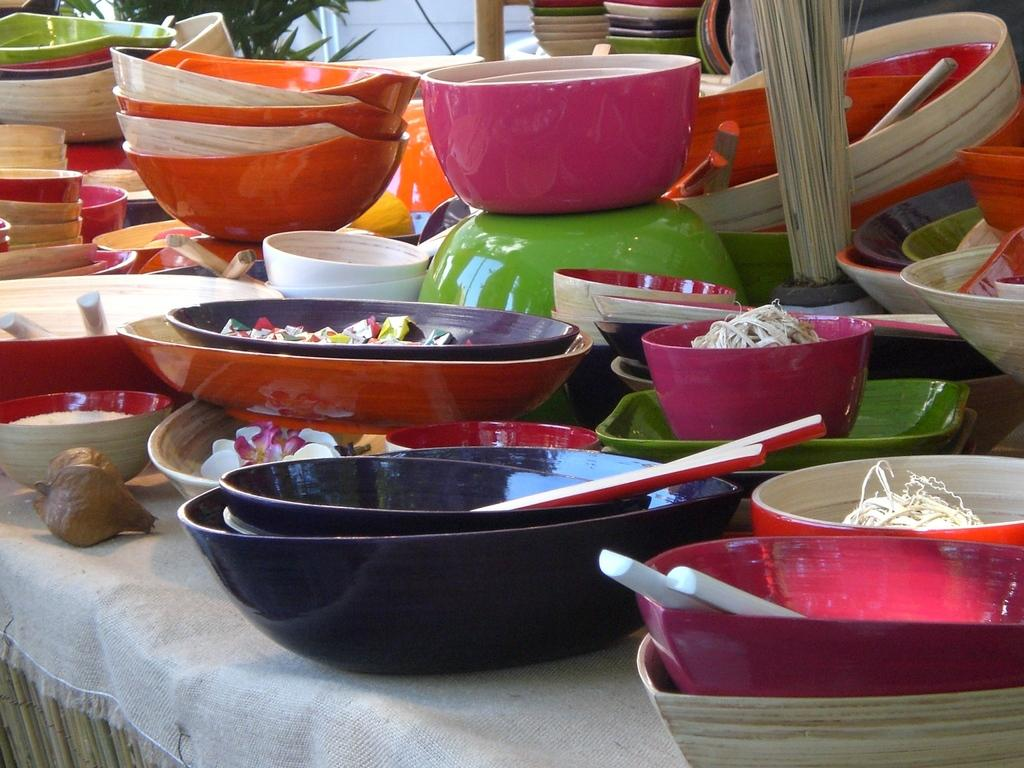What type of dishware is on the table in the image? There are multi-color bowls on the table. What is covering the table in the image? There is a white cloth in the image. What can be seen in the background of the image? There are plants in the background of the image. What is the color of the plants in the image? The plants are green in color. Is there a snake resting on the table in the image? No, there is no snake present in the image. Can you see a tramp in the background of the image? No, there is no tramp present in the image. 